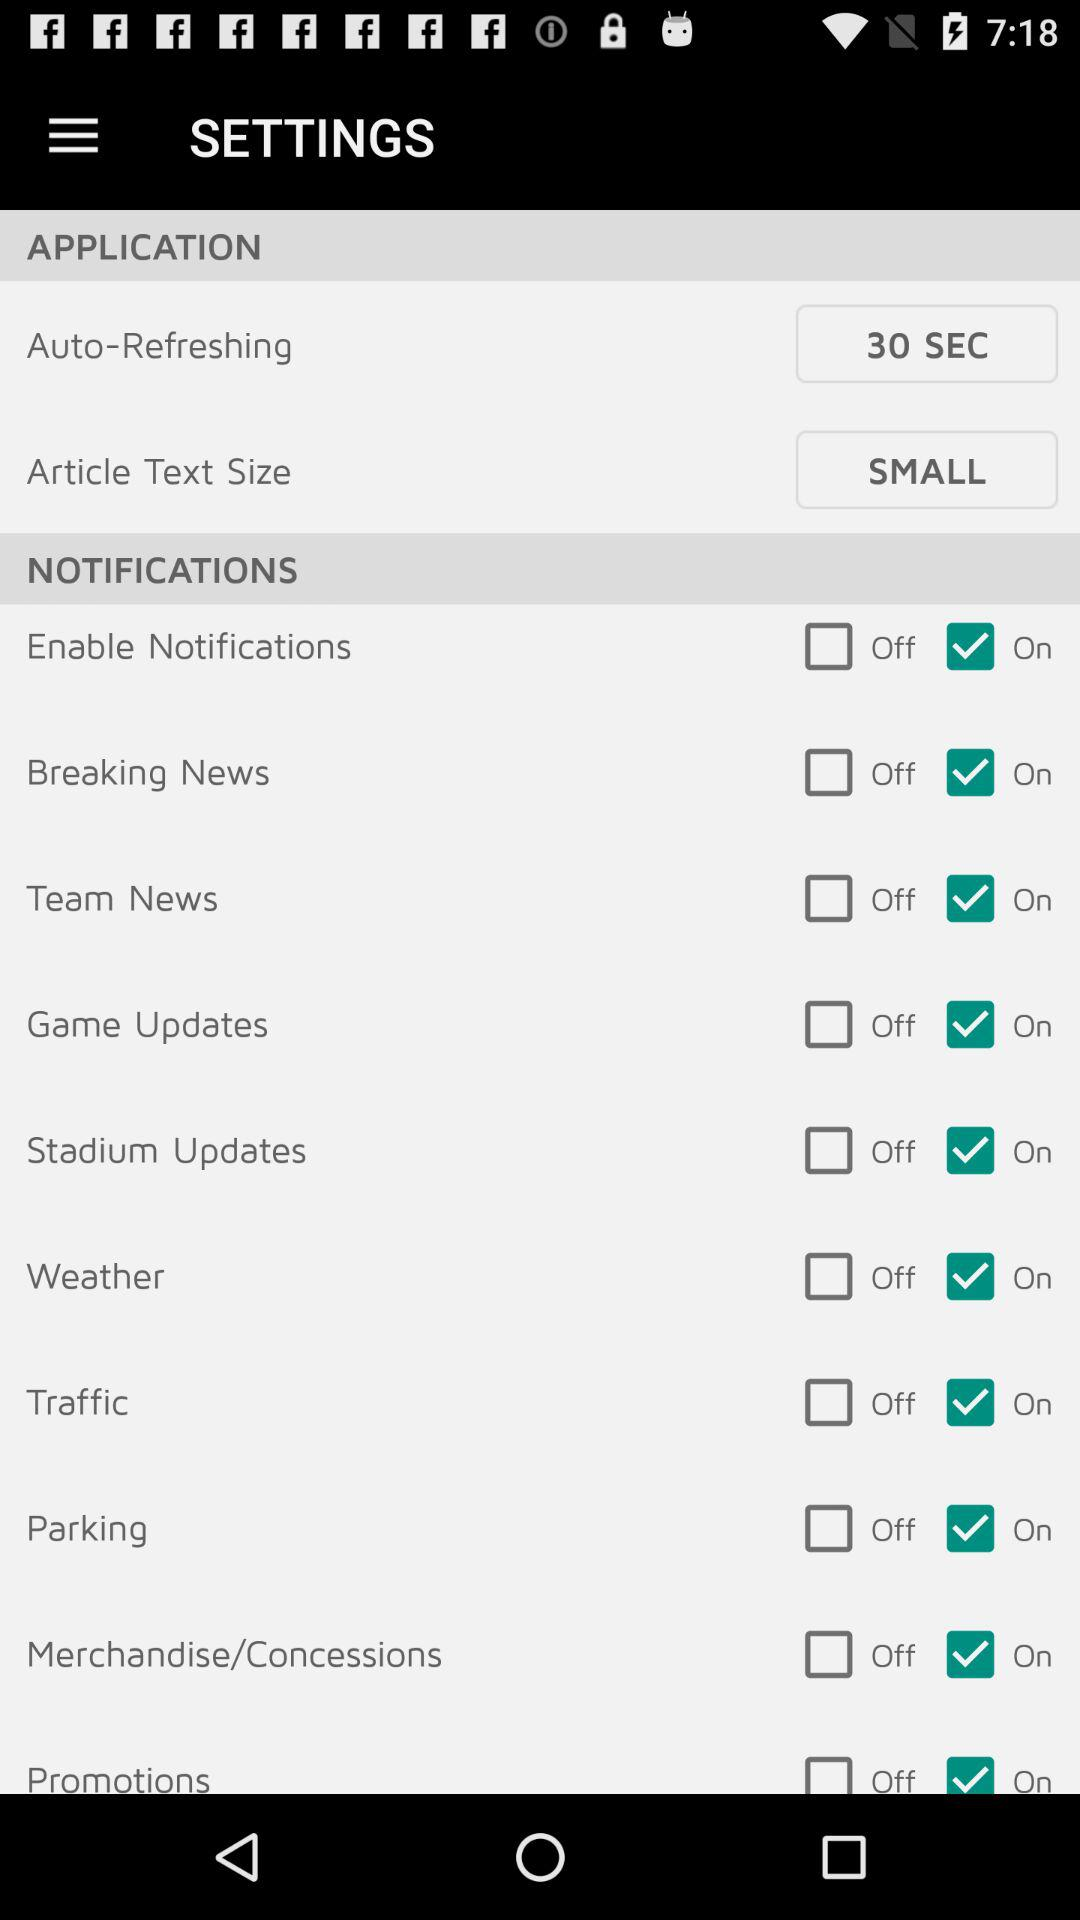What's the auto-refreshing time? The auto-refreshing time is 30 seconds. 